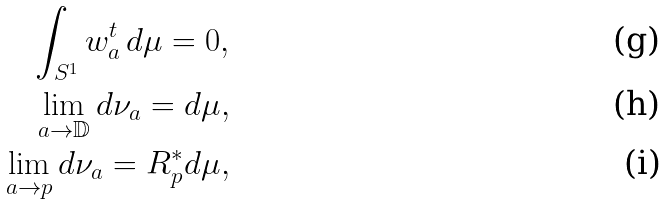Convert formula to latex. <formula><loc_0><loc_0><loc_500><loc_500>\int _ { S ^ { 1 } } w _ { a } ^ { t } \, d \mu = 0 , \\ \lim _ { a \rightarrow \mathbb { D } } d \nu _ { a } = d \mu , \\ \lim _ { a \rightarrow p } d \nu _ { a } = R _ { p } ^ { * } d \mu ,</formula> 